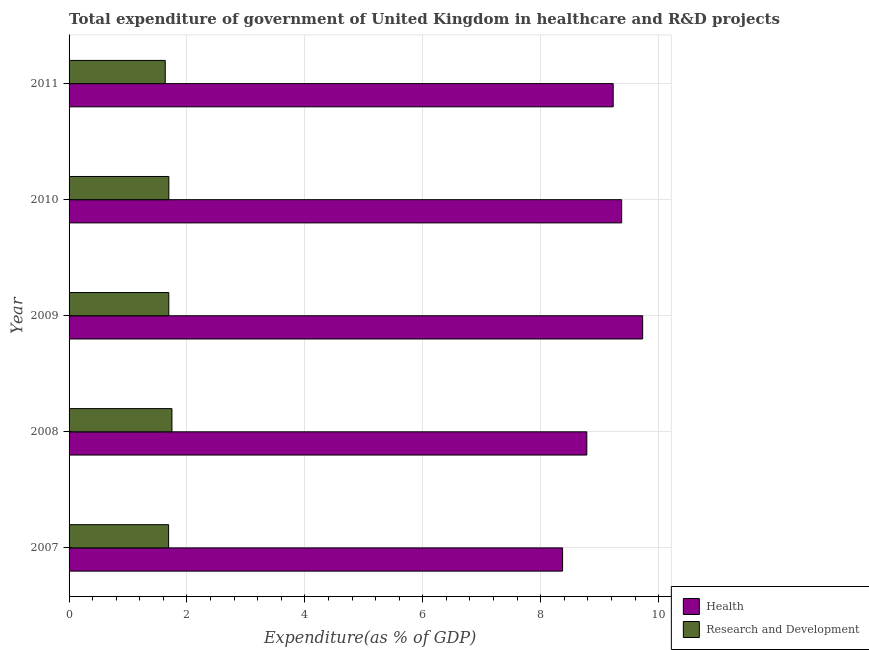How many different coloured bars are there?
Provide a succinct answer. 2. How many bars are there on the 3rd tick from the top?
Your response must be concise. 2. What is the label of the 4th group of bars from the top?
Your response must be concise. 2008. What is the expenditure in r&d in 2011?
Make the answer very short. 1.63. Across all years, what is the maximum expenditure in r&d?
Make the answer very short. 1.75. Across all years, what is the minimum expenditure in healthcare?
Make the answer very short. 8.37. What is the total expenditure in r&d in the graph?
Make the answer very short. 8.45. What is the difference between the expenditure in r&d in 2009 and that in 2010?
Give a very brief answer. -0. What is the difference between the expenditure in r&d in 2008 and the expenditure in healthcare in 2011?
Offer a terse response. -7.49. What is the average expenditure in healthcare per year?
Make the answer very short. 9.1. In the year 2010, what is the difference between the expenditure in healthcare and expenditure in r&d?
Your response must be concise. 7.68. What is the ratio of the expenditure in r&d in 2008 to that in 2010?
Your answer should be very brief. 1.03. What is the difference between the highest and the second highest expenditure in r&d?
Your answer should be very brief. 0.05. What is the difference between the highest and the lowest expenditure in healthcare?
Your answer should be very brief. 1.36. Is the sum of the expenditure in healthcare in 2007 and 2010 greater than the maximum expenditure in r&d across all years?
Your answer should be very brief. Yes. What does the 2nd bar from the top in 2011 represents?
Offer a very short reply. Health. What does the 2nd bar from the bottom in 2007 represents?
Your answer should be very brief. Research and Development. Are all the bars in the graph horizontal?
Ensure brevity in your answer.  Yes. How many years are there in the graph?
Offer a very short reply. 5. What is the difference between two consecutive major ticks on the X-axis?
Offer a terse response. 2. Are the values on the major ticks of X-axis written in scientific E-notation?
Offer a very short reply. No. Does the graph contain any zero values?
Keep it short and to the point. No. How are the legend labels stacked?
Give a very brief answer. Vertical. What is the title of the graph?
Keep it short and to the point. Total expenditure of government of United Kingdom in healthcare and R&D projects. What is the label or title of the X-axis?
Make the answer very short. Expenditure(as % of GDP). What is the label or title of the Y-axis?
Make the answer very short. Year. What is the Expenditure(as % of GDP) in Health in 2007?
Offer a terse response. 8.37. What is the Expenditure(as % of GDP) of Research and Development in 2007?
Offer a very short reply. 1.69. What is the Expenditure(as % of GDP) of Health in 2008?
Your answer should be very brief. 8.78. What is the Expenditure(as % of GDP) of Research and Development in 2008?
Your response must be concise. 1.75. What is the Expenditure(as % of GDP) in Health in 2009?
Your answer should be very brief. 9.73. What is the Expenditure(as % of GDP) in Research and Development in 2009?
Provide a succinct answer. 1.69. What is the Expenditure(as % of GDP) in Health in 2010?
Provide a short and direct response. 9.37. What is the Expenditure(as % of GDP) of Research and Development in 2010?
Offer a very short reply. 1.69. What is the Expenditure(as % of GDP) of Health in 2011?
Offer a very short reply. 9.23. What is the Expenditure(as % of GDP) in Research and Development in 2011?
Offer a very short reply. 1.63. Across all years, what is the maximum Expenditure(as % of GDP) of Health?
Your answer should be very brief. 9.73. Across all years, what is the maximum Expenditure(as % of GDP) in Research and Development?
Ensure brevity in your answer.  1.75. Across all years, what is the minimum Expenditure(as % of GDP) of Health?
Provide a short and direct response. 8.37. Across all years, what is the minimum Expenditure(as % of GDP) of Research and Development?
Provide a succinct answer. 1.63. What is the total Expenditure(as % of GDP) of Health in the graph?
Keep it short and to the point. 45.49. What is the total Expenditure(as % of GDP) in Research and Development in the graph?
Your response must be concise. 8.45. What is the difference between the Expenditure(as % of GDP) in Health in 2007 and that in 2008?
Ensure brevity in your answer.  -0.41. What is the difference between the Expenditure(as % of GDP) of Research and Development in 2007 and that in 2008?
Keep it short and to the point. -0.06. What is the difference between the Expenditure(as % of GDP) in Health in 2007 and that in 2009?
Give a very brief answer. -1.36. What is the difference between the Expenditure(as % of GDP) in Research and Development in 2007 and that in 2009?
Offer a terse response. -0. What is the difference between the Expenditure(as % of GDP) in Health in 2007 and that in 2010?
Provide a succinct answer. -1. What is the difference between the Expenditure(as % of GDP) of Research and Development in 2007 and that in 2010?
Keep it short and to the point. -0. What is the difference between the Expenditure(as % of GDP) of Health in 2007 and that in 2011?
Keep it short and to the point. -0.86. What is the difference between the Expenditure(as % of GDP) in Research and Development in 2007 and that in 2011?
Offer a very short reply. 0.06. What is the difference between the Expenditure(as % of GDP) of Health in 2008 and that in 2009?
Provide a succinct answer. -0.95. What is the difference between the Expenditure(as % of GDP) of Research and Development in 2008 and that in 2009?
Provide a succinct answer. 0.05. What is the difference between the Expenditure(as % of GDP) in Health in 2008 and that in 2010?
Offer a very short reply. -0.59. What is the difference between the Expenditure(as % of GDP) in Research and Development in 2008 and that in 2010?
Provide a short and direct response. 0.05. What is the difference between the Expenditure(as % of GDP) of Health in 2008 and that in 2011?
Offer a very short reply. -0.45. What is the difference between the Expenditure(as % of GDP) in Research and Development in 2008 and that in 2011?
Provide a succinct answer. 0.11. What is the difference between the Expenditure(as % of GDP) in Health in 2009 and that in 2010?
Give a very brief answer. 0.36. What is the difference between the Expenditure(as % of GDP) in Research and Development in 2009 and that in 2010?
Offer a very short reply. -0. What is the difference between the Expenditure(as % of GDP) in Health in 2009 and that in 2011?
Provide a short and direct response. 0.5. What is the difference between the Expenditure(as % of GDP) in Research and Development in 2009 and that in 2011?
Your answer should be compact. 0.06. What is the difference between the Expenditure(as % of GDP) of Health in 2010 and that in 2011?
Offer a very short reply. 0.14. What is the difference between the Expenditure(as % of GDP) of Research and Development in 2010 and that in 2011?
Provide a succinct answer. 0.06. What is the difference between the Expenditure(as % of GDP) of Health in 2007 and the Expenditure(as % of GDP) of Research and Development in 2008?
Keep it short and to the point. 6.63. What is the difference between the Expenditure(as % of GDP) of Health in 2007 and the Expenditure(as % of GDP) of Research and Development in 2009?
Ensure brevity in your answer.  6.68. What is the difference between the Expenditure(as % of GDP) of Health in 2007 and the Expenditure(as % of GDP) of Research and Development in 2010?
Provide a succinct answer. 6.68. What is the difference between the Expenditure(as % of GDP) of Health in 2007 and the Expenditure(as % of GDP) of Research and Development in 2011?
Your answer should be compact. 6.74. What is the difference between the Expenditure(as % of GDP) in Health in 2008 and the Expenditure(as % of GDP) in Research and Development in 2009?
Make the answer very short. 7.09. What is the difference between the Expenditure(as % of GDP) of Health in 2008 and the Expenditure(as % of GDP) of Research and Development in 2010?
Provide a short and direct response. 7.09. What is the difference between the Expenditure(as % of GDP) of Health in 2008 and the Expenditure(as % of GDP) of Research and Development in 2011?
Provide a short and direct response. 7.15. What is the difference between the Expenditure(as % of GDP) of Health in 2009 and the Expenditure(as % of GDP) of Research and Development in 2010?
Provide a short and direct response. 8.04. What is the difference between the Expenditure(as % of GDP) of Health in 2009 and the Expenditure(as % of GDP) of Research and Development in 2011?
Ensure brevity in your answer.  8.1. What is the difference between the Expenditure(as % of GDP) in Health in 2010 and the Expenditure(as % of GDP) in Research and Development in 2011?
Offer a terse response. 7.74. What is the average Expenditure(as % of GDP) in Health per year?
Offer a very short reply. 9.1. What is the average Expenditure(as % of GDP) in Research and Development per year?
Provide a succinct answer. 1.69. In the year 2007, what is the difference between the Expenditure(as % of GDP) in Health and Expenditure(as % of GDP) in Research and Development?
Your response must be concise. 6.68. In the year 2008, what is the difference between the Expenditure(as % of GDP) of Health and Expenditure(as % of GDP) of Research and Development?
Your answer should be compact. 7.04. In the year 2009, what is the difference between the Expenditure(as % of GDP) of Health and Expenditure(as % of GDP) of Research and Development?
Your response must be concise. 8.04. In the year 2010, what is the difference between the Expenditure(as % of GDP) of Health and Expenditure(as % of GDP) of Research and Development?
Your response must be concise. 7.68. In the year 2011, what is the difference between the Expenditure(as % of GDP) of Health and Expenditure(as % of GDP) of Research and Development?
Your response must be concise. 7.6. What is the ratio of the Expenditure(as % of GDP) of Health in 2007 to that in 2008?
Your response must be concise. 0.95. What is the ratio of the Expenditure(as % of GDP) of Research and Development in 2007 to that in 2008?
Offer a very short reply. 0.97. What is the ratio of the Expenditure(as % of GDP) of Health in 2007 to that in 2009?
Your answer should be compact. 0.86. What is the ratio of the Expenditure(as % of GDP) in Research and Development in 2007 to that in 2009?
Your answer should be compact. 1. What is the ratio of the Expenditure(as % of GDP) in Health in 2007 to that in 2010?
Make the answer very short. 0.89. What is the ratio of the Expenditure(as % of GDP) in Research and Development in 2007 to that in 2010?
Offer a very short reply. 1. What is the ratio of the Expenditure(as % of GDP) in Health in 2007 to that in 2011?
Your response must be concise. 0.91. What is the ratio of the Expenditure(as % of GDP) of Research and Development in 2007 to that in 2011?
Offer a very short reply. 1.03. What is the ratio of the Expenditure(as % of GDP) in Health in 2008 to that in 2009?
Ensure brevity in your answer.  0.9. What is the ratio of the Expenditure(as % of GDP) of Research and Development in 2008 to that in 2009?
Make the answer very short. 1.03. What is the ratio of the Expenditure(as % of GDP) of Health in 2008 to that in 2010?
Ensure brevity in your answer.  0.94. What is the ratio of the Expenditure(as % of GDP) in Research and Development in 2008 to that in 2010?
Give a very brief answer. 1.03. What is the ratio of the Expenditure(as % of GDP) in Health in 2008 to that in 2011?
Your response must be concise. 0.95. What is the ratio of the Expenditure(as % of GDP) in Research and Development in 2008 to that in 2011?
Keep it short and to the point. 1.07. What is the ratio of the Expenditure(as % of GDP) in Health in 2009 to that in 2010?
Your response must be concise. 1.04. What is the ratio of the Expenditure(as % of GDP) in Health in 2009 to that in 2011?
Your answer should be very brief. 1.05. What is the ratio of the Expenditure(as % of GDP) of Research and Development in 2009 to that in 2011?
Your answer should be compact. 1.04. What is the ratio of the Expenditure(as % of GDP) of Health in 2010 to that in 2011?
Offer a very short reply. 1.02. What is the ratio of the Expenditure(as % of GDP) in Research and Development in 2010 to that in 2011?
Make the answer very short. 1.04. What is the difference between the highest and the second highest Expenditure(as % of GDP) of Health?
Your answer should be compact. 0.36. What is the difference between the highest and the second highest Expenditure(as % of GDP) in Research and Development?
Your response must be concise. 0.05. What is the difference between the highest and the lowest Expenditure(as % of GDP) of Health?
Your answer should be compact. 1.36. What is the difference between the highest and the lowest Expenditure(as % of GDP) in Research and Development?
Your response must be concise. 0.11. 